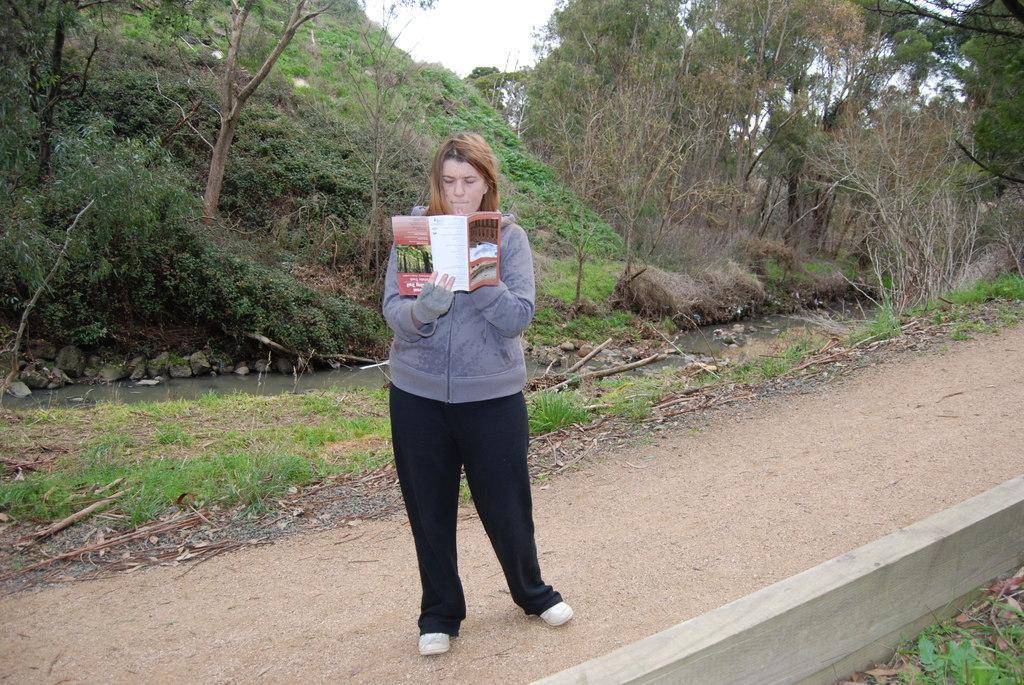Can you describe this image briefly? There is a person standing and holding a book. Background we can see trees,grass and sky. 